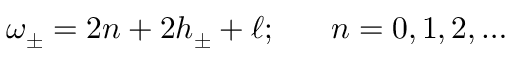<formula> <loc_0><loc_0><loc_500><loc_500>\omega _ { \pm } = 2 n + 2 h _ { \pm } + \ell ; n = 0 , 1 , 2 , \dots</formula> 